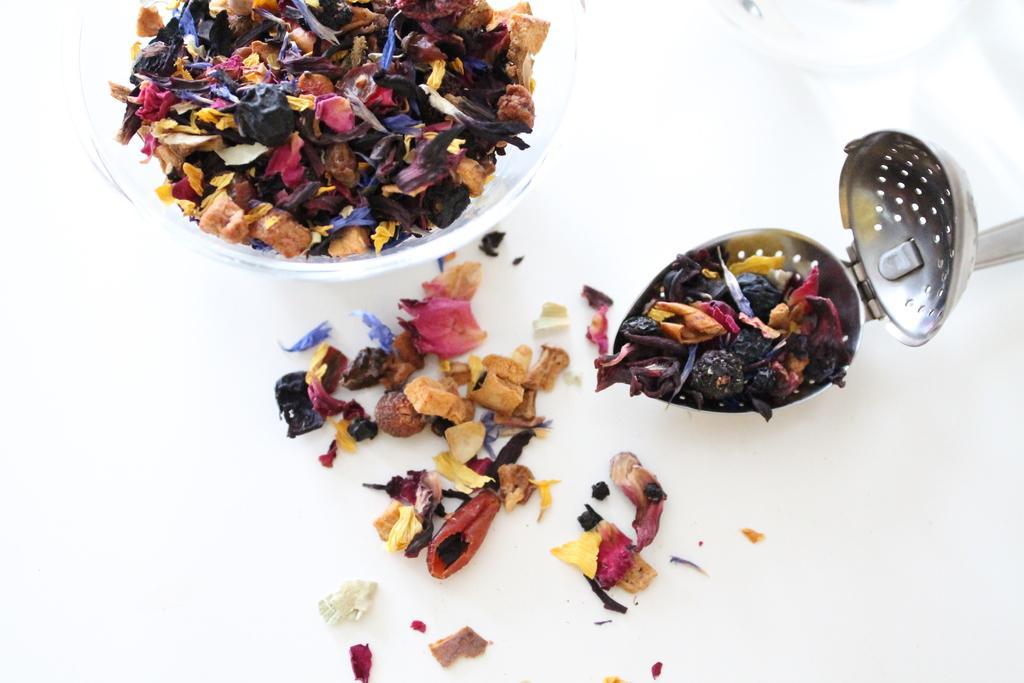Please provide a concise description of this image. In the image there are superfoods kept in a bowl and some of them were fell down beside the the bowl and they are also kept in a container on the right side. 